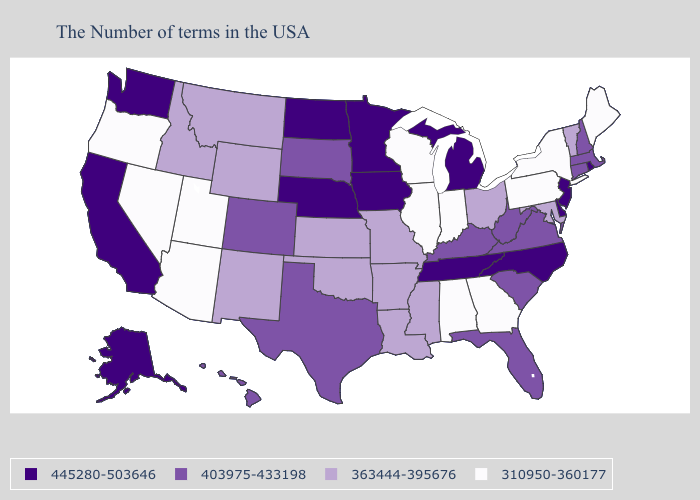What is the value of Hawaii?
Keep it brief. 403975-433198. Does North Carolina have the highest value in the South?
Be succinct. Yes. What is the value of Rhode Island?
Give a very brief answer. 445280-503646. Name the states that have a value in the range 445280-503646?
Write a very short answer. Rhode Island, New Jersey, Delaware, North Carolina, Michigan, Tennessee, Minnesota, Iowa, Nebraska, North Dakota, California, Washington, Alaska. What is the value of Florida?
Answer briefly. 403975-433198. Does Illinois have the lowest value in the USA?
Quick response, please. Yes. Name the states that have a value in the range 310950-360177?
Keep it brief. Maine, New York, Pennsylvania, Georgia, Indiana, Alabama, Wisconsin, Illinois, Utah, Arizona, Nevada, Oregon. Does the first symbol in the legend represent the smallest category?
Concise answer only. No. What is the lowest value in the South?
Keep it brief. 310950-360177. Does the map have missing data?
Keep it brief. No. Among the states that border Vermont , does New York have the highest value?
Quick response, please. No. Name the states that have a value in the range 363444-395676?
Concise answer only. Vermont, Maryland, Ohio, Mississippi, Louisiana, Missouri, Arkansas, Kansas, Oklahoma, Wyoming, New Mexico, Montana, Idaho. Does the first symbol in the legend represent the smallest category?
Be succinct. No. Does Iowa have the same value as Montana?
Concise answer only. No. Name the states that have a value in the range 310950-360177?
Quick response, please. Maine, New York, Pennsylvania, Georgia, Indiana, Alabama, Wisconsin, Illinois, Utah, Arizona, Nevada, Oregon. 